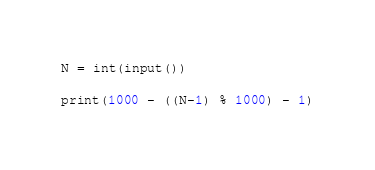Convert code to text. <code><loc_0><loc_0><loc_500><loc_500><_Python_>N = int(input())

print(1000 - ((N-1) % 1000) - 1)</code> 